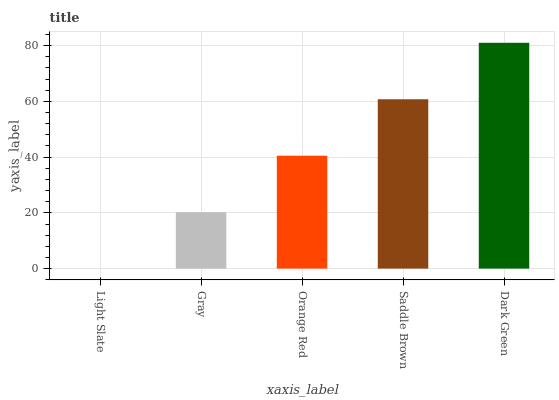Is Light Slate the minimum?
Answer yes or no. Yes. Is Dark Green the maximum?
Answer yes or no. Yes. Is Gray the minimum?
Answer yes or no. No. Is Gray the maximum?
Answer yes or no. No. Is Gray greater than Light Slate?
Answer yes or no. Yes. Is Light Slate less than Gray?
Answer yes or no. Yes. Is Light Slate greater than Gray?
Answer yes or no. No. Is Gray less than Light Slate?
Answer yes or no. No. Is Orange Red the high median?
Answer yes or no. Yes. Is Orange Red the low median?
Answer yes or no. Yes. Is Light Slate the high median?
Answer yes or no. No. Is Light Slate the low median?
Answer yes or no. No. 